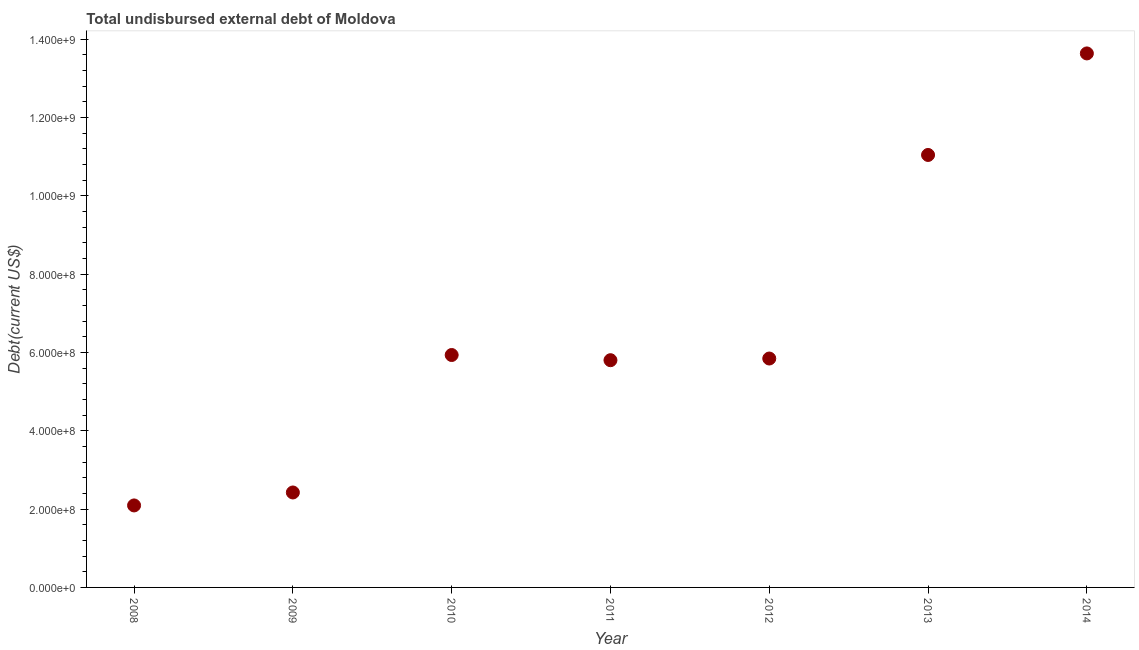What is the total debt in 2014?
Ensure brevity in your answer.  1.36e+09. Across all years, what is the maximum total debt?
Your answer should be very brief. 1.36e+09. Across all years, what is the minimum total debt?
Offer a very short reply. 2.09e+08. What is the sum of the total debt?
Ensure brevity in your answer.  4.68e+09. What is the difference between the total debt in 2008 and 2013?
Provide a short and direct response. -8.95e+08. What is the average total debt per year?
Provide a succinct answer. 6.68e+08. What is the median total debt?
Ensure brevity in your answer.  5.85e+08. What is the ratio of the total debt in 2008 to that in 2013?
Provide a succinct answer. 0.19. Is the total debt in 2010 less than that in 2013?
Keep it short and to the point. Yes. Is the difference between the total debt in 2008 and 2014 greater than the difference between any two years?
Make the answer very short. Yes. What is the difference between the highest and the second highest total debt?
Provide a short and direct response. 2.59e+08. What is the difference between the highest and the lowest total debt?
Offer a terse response. 1.15e+09. In how many years, is the total debt greater than the average total debt taken over all years?
Provide a succinct answer. 2. What is the title of the graph?
Provide a succinct answer. Total undisbursed external debt of Moldova. What is the label or title of the Y-axis?
Your answer should be very brief. Debt(current US$). What is the Debt(current US$) in 2008?
Your answer should be compact. 2.09e+08. What is the Debt(current US$) in 2009?
Provide a succinct answer. 2.42e+08. What is the Debt(current US$) in 2010?
Offer a terse response. 5.94e+08. What is the Debt(current US$) in 2011?
Your answer should be compact. 5.80e+08. What is the Debt(current US$) in 2012?
Give a very brief answer. 5.85e+08. What is the Debt(current US$) in 2013?
Your answer should be compact. 1.10e+09. What is the Debt(current US$) in 2014?
Offer a very short reply. 1.36e+09. What is the difference between the Debt(current US$) in 2008 and 2009?
Your response must be concise. -3.31e+07. What is the difference between the Debt(current US$) in 2008 and 2010?
Offer a very short reply. -3.84e+08. What is the difference between the Debt(current US$) in 2008 and 2011?
Offer a terse response. -3.71e+08. What is the difference between the Debt(current US$) in 2008 and 2012?
Provide a succinct answer. -3.75e+08. What is the difference between the Debt(current US$) in 2008 and 2013?
Ensure brevity in your answer.  -8.95e+08. What is the difference between the Debt(current US$) in 2008 and 2014?
Offer a terse response. -1.15e+09. What is the difference between the Debt(current US$) in 2009 and 2010?
Provide a short and direct response. -3.51e+08. What is the difference between the Debt(current US$) in 2009 and 2011?
Your answer should be compact. -3.38e+08. What is the difference between the Debt(current US$) in 2009 and 2012?
Your answer should be compact. -3.42e+08. What is the difference between the Debt(current US$) in 2009 and 2013?
Your answer should be very brief. -8.62e+08. What is the difference between the Debt(current US$) in 2009 and 2014?
Offer a very short reply. -1.12e+09. What is the difference between the Debt(current US$) in 2010 and 2011?
Make the answer very short. 1.33e+07. What is the difference between the Debt(current US$) in 2010 and 2012?
Ensure brevity in your answer.  8.98e+06. What is the difference between the Debt(current US$) in 2010 and 2013?
Make the answer very short. -5.11e+08. What is the difference between the Debt(current US$) in 2010 and 2014?
Keep it short and to the point. -7.70e+08. What is the difference between the Debt(current US$) in 2011 and 2012?
Your answer should be very brief. -4.28e+06. What is the difference between the Debt(current US$) in 2011 and 2013?
Your answer should be compact. -5.24e+08. What is the difference between the Debt(current US$) in 2011 and 2014?
Give a very brief answer. -7.83e+08. What is the difference between the Debt(current US$) in 2012 and 2013?
Offer a very short reply. -5.20e+08. What is the difference between the Debt(current US$) in 2012 and 2014?
Provide a succinct answer. -7.79e+08. What is the difference between the Debt(current US$) in 2013 and 2014?
Provide a succinct answer. -2.59e+08. What is the ratio of the Debt(current US$) in 2008 to that in 2009?
Keep it short and to the point. 0.86. What is the ratio of the Debt(current US$) in 2008 to that in 2010?
Your answer should be compact. 0.35. What is the ratio of the Debt(current US$) in 2008 to that in 2011?
Provide a succinct answer. 0.36. What is the ratio of the Debt(current US$) in 2008 to that in 2012?
Provide a succinct answer. 0.36. What is the ratio of the Debt(current US$) in 2008 to that in 2013?
Your answer should be very brief. 0.19. What is the ratio of the Debt(current US$) in 2008 to that in 2014?
Ensure brevity in your answer.  0.15. What is the ratio of the Debt(current US$) in 2009 to that in 2010?
Provide a succinct answer. 0.41. What is the ratio of the Debt(current US$) in 2009 to that in 2011?
Your answer should be very brief. 0.42. What is the ratio of the Debt(current US$) in 2009 to that in 2012?
Provide a succinct answer. 0.41. What is the ratio of the Debt(current US$) in 2009 to that in 2013?
Your response must be concise. 0.22. What is the ratio of the Debt(current US$) in 2009 to that in 2014?
Give a very brief answer. 0.18. What is the ratio of the Debt(current US$) in 2010 to that in 2011?
Make the answer very short. 1.02. What is the ratio of the Debt(current US$) in 2010 to that in 2013?
Keep it short and to the point. 0.54. What is the ratio of the Debt(current US$) in 2010 to that in 2014?
Ensure brevity in your answer.  0.43. What is the ratio of the Debt(current US$) in 2011 to that in 2013?
Your answer should be very brief. 0.53. What is the ratio of the Debt(current US$) in 2011 to that in 2014?
Ensure brevity in your answer.  0.43. What is the ratio of the Debt(current US$) in 2012 to that in 2013?
Make the answer very short. 0.53. What is the ratio of the Debt(current US$) in 2012 to that in 2014?
Your response must be concise. 0.43. What is the ratio of the Debt(current US$) in 2013 to that in 2014?
Offer a terse response. 0.81. 